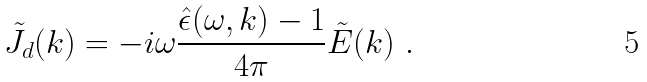Convert formula to latex. <formula><loc_0><loc_0><loc_500><loc_500>\tilde { J } _ { d } ( { k } ) = - i \omega \frac { \hat { \epsilon } ( \omega , { k } ) - 1 } { 4 \pi } \tilde { E } ( { k } ) \ .</formula> 